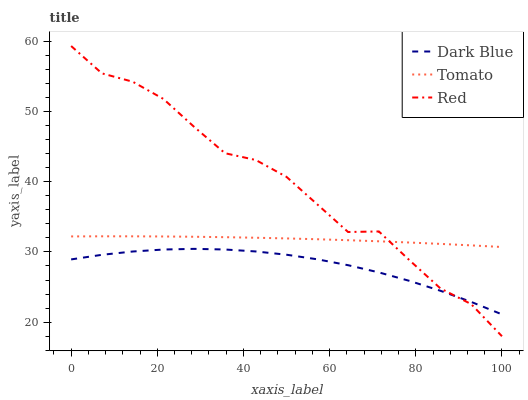Does Dark Blue have the minimum area under the curve?
Answer yes or no. Yes. Does Red have the maximum area under the curve?
Answer yes or no. Yes. Does Red have the minimum area under the curve?
Answer yes or no. No. Does Dark Blue have the maximum area under the curve?
Answer yes or no. No. Is Tomato the smoothest?
Answer yes or no. Yes. Is Red the roughest?
Answer yes or no. Yes. Is Dark Blue the smoothest?
Answer yes or no. No. Is Dark Blue the roughest?
Answer yes or no. No. Does Dark Blue have the lowest value?
Answer yes or no. No. Does Red have the highest value?
Answer yes or no. Yes. Does Dark Blue have the highest value?
Answer yes or no. No. Is Dark Blue less than Tomato?
Answer yes or no. Yes. Is Tomato greater than Dark Blue?
Answer yes or no. Yes. Does Tomato intersect Red?
Answer yes or no. Yes. Is Tomato less than Red?
Answer yes or no. No. Is Tomato greater than Red?
Answer yes or no. No. Does Dark Blue intersect Tomato?
Answer yes or no. No. 